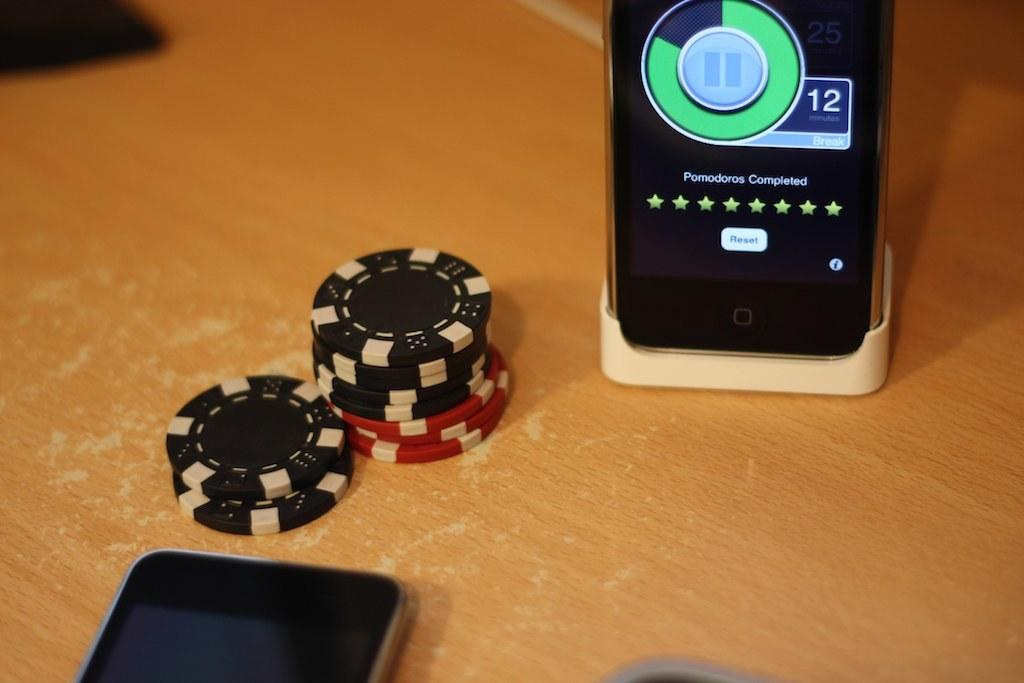Provide a one-sentence caption for the provided image. A small stack of poker chips sit by a cellphone with the volume set to 12. 